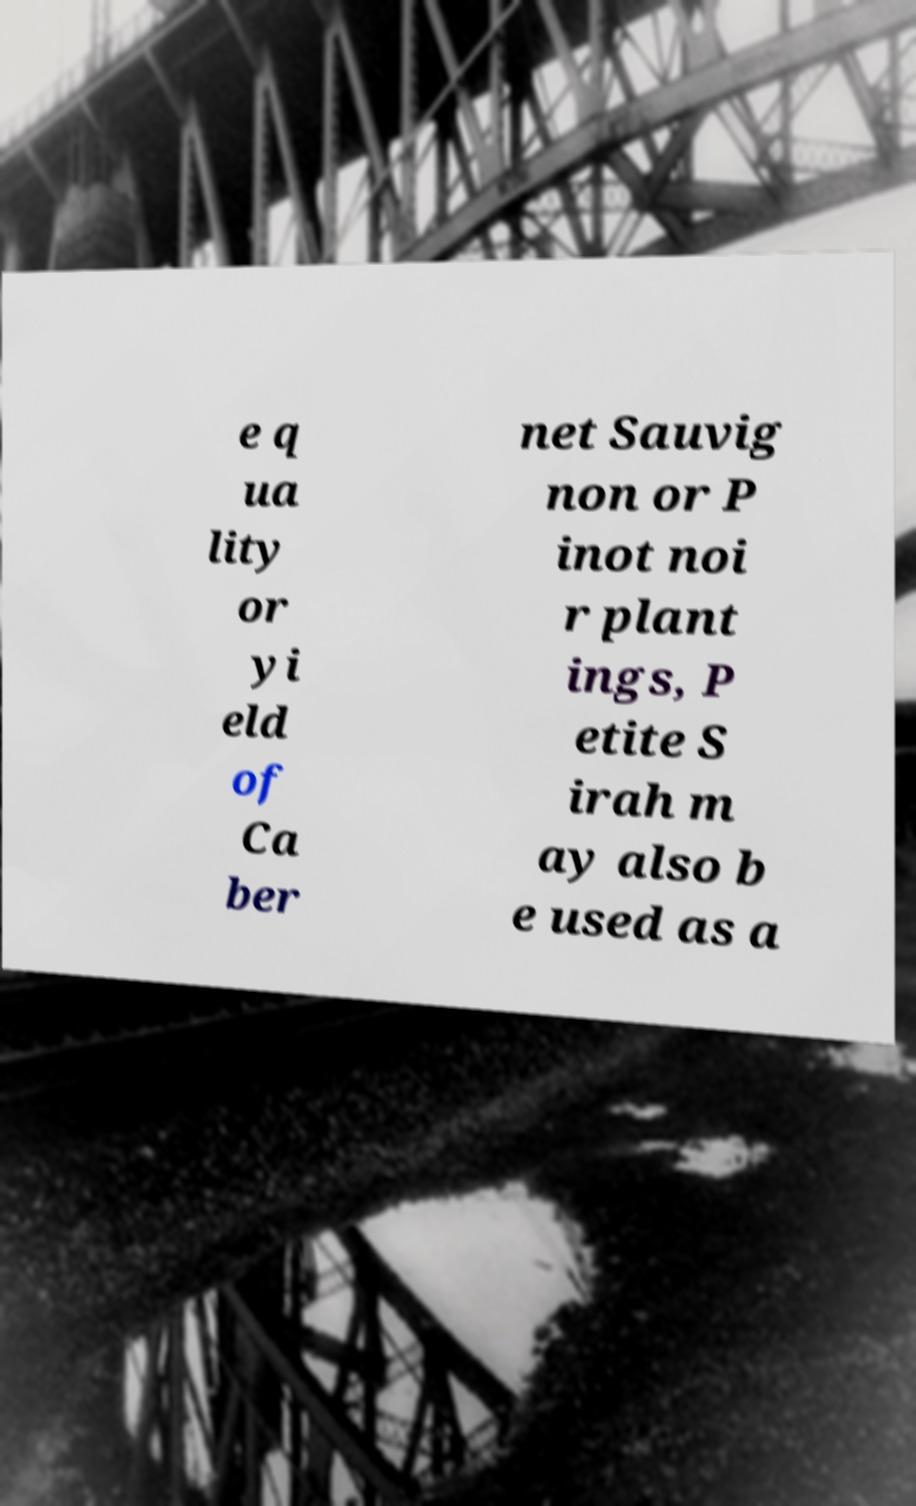I need the written content from this picture converted into text. Can you do that? e q ua lity or yi eld of Ca ber net Sauvig non or P inot noi r plant ings, P etite S irah m ay also b e used as a 